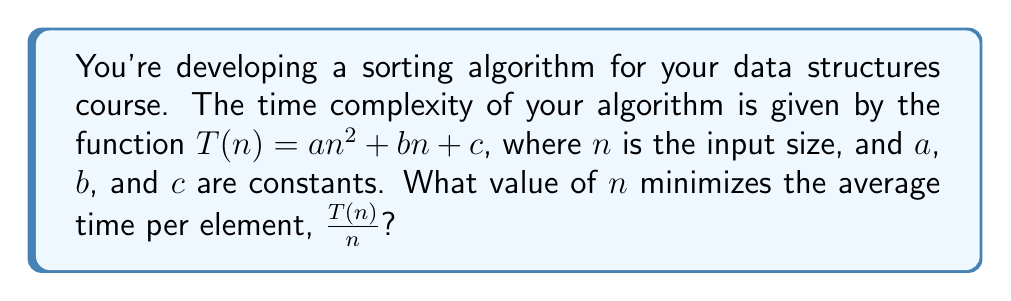Can you solve this math problem? Let's approach this step-by-step:

1) The average time per element is given by $\frac{T(n)}{n}$:

   $$\frac{T(n)}{n} = \frac{an^2 + bn + c}{n} = an + b + \frac{c}{n}$$

2) To find the minimum, we need to differentiate this function with respect to $n$ and set it to zero:

   $$\frac{d}{dn}(an + b + \frac{c}{n}) = a - \frac{c}{n^2}$$

3) Setting this equal to zero:

   $$a - \frac{c}{n^2} = 0$$

4) Solving for $n$:

   $$\frac{c}{n^2} = a$$
   $$c = an^2$$
   $$n^2 = \frac{c}{a}$$
   $$n = \sqrt{\frac{c}{a}}$$

5) To confirm this is a minimum (not a maximum), we can check the second derivative:

   $$\frac{d^2}{dn^2}(an + b + \frac{c}{n}) = \frac{2c}{n^3}$$

   This is always positive for positive $n$, confirming we've found a minimum.
Answer: $n = \sqrt{\frac{c}{a}}$ 